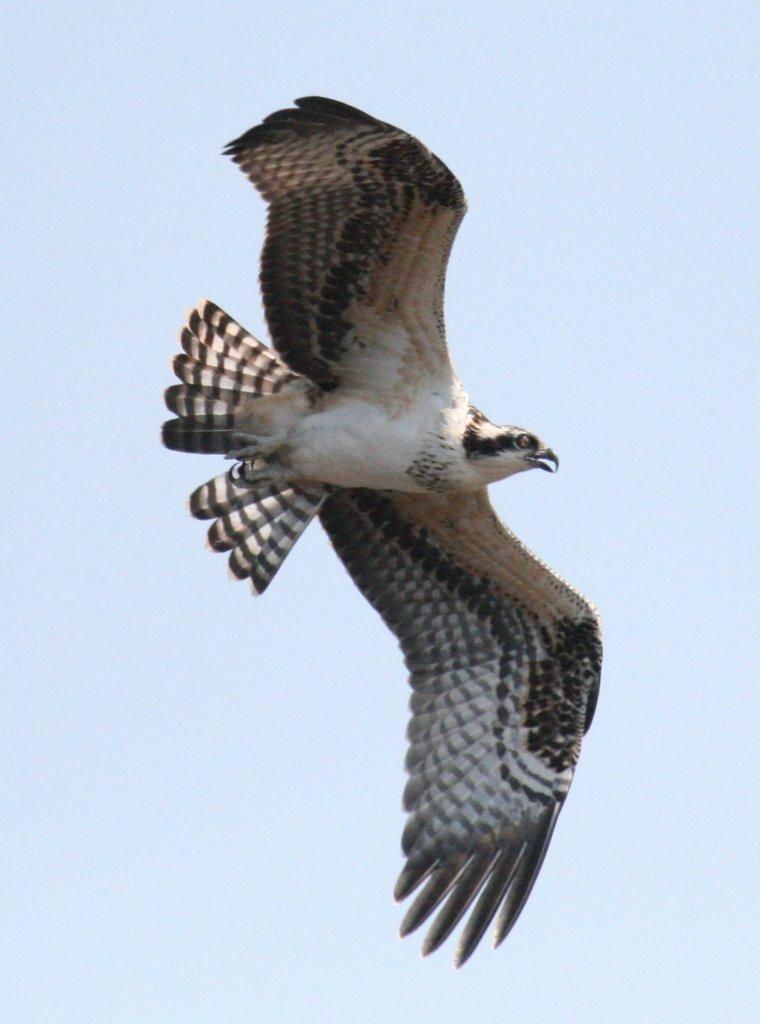Describe this image in one or two sentences. In the center of the image we can see a bird flying in the sky. 